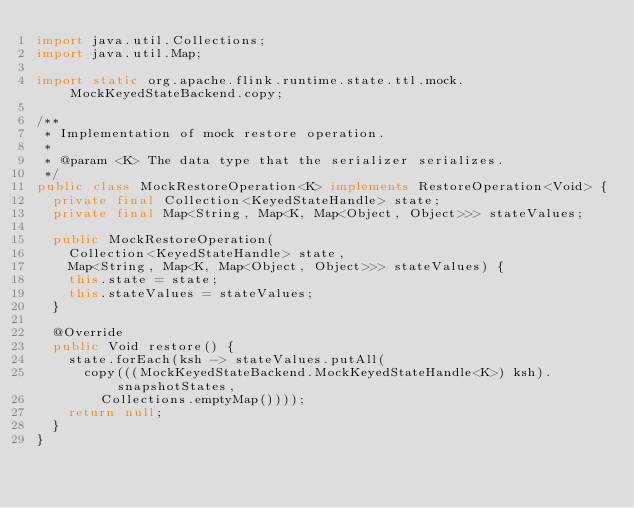Convert code to text. <code><loc_0><loc_0><loc_500><loc_500><_Java_>import java.util.Collections;
import java.util.Map;

import static org.apache.flink.runtime.state.ttl.mock.MockKeyedStateBackend.copy;

/**
 * Implementation of mock restore operation.
 *
 * @param <K> The data type that the serializer serializes.
 */
public class MockRestoreOperation<K> implements RestoreOperation<Void> {
	private final Collection<KeyedStateHandle> state;
	private final Map<String, Map<K, Map<Object, Object>>> stateValues;

	public MockRestoreOperation(
		Collection<KeyedStateHandle> state,
		Map<String, Map<K, Map<Object, Object>>> stateValues) {
		this.state = state;
		this.stateValues = stateValues;
	}

	@Override
	public Void restore() {
		state.forEach(ksh -> stateValues.putAll(
			copy(((MockKeyedStateBackend.MockKeyedStateHandle<K>) ksh).snapshotStates,
				Collections.emptyMap())));
		return null;
	}
}
</code> 